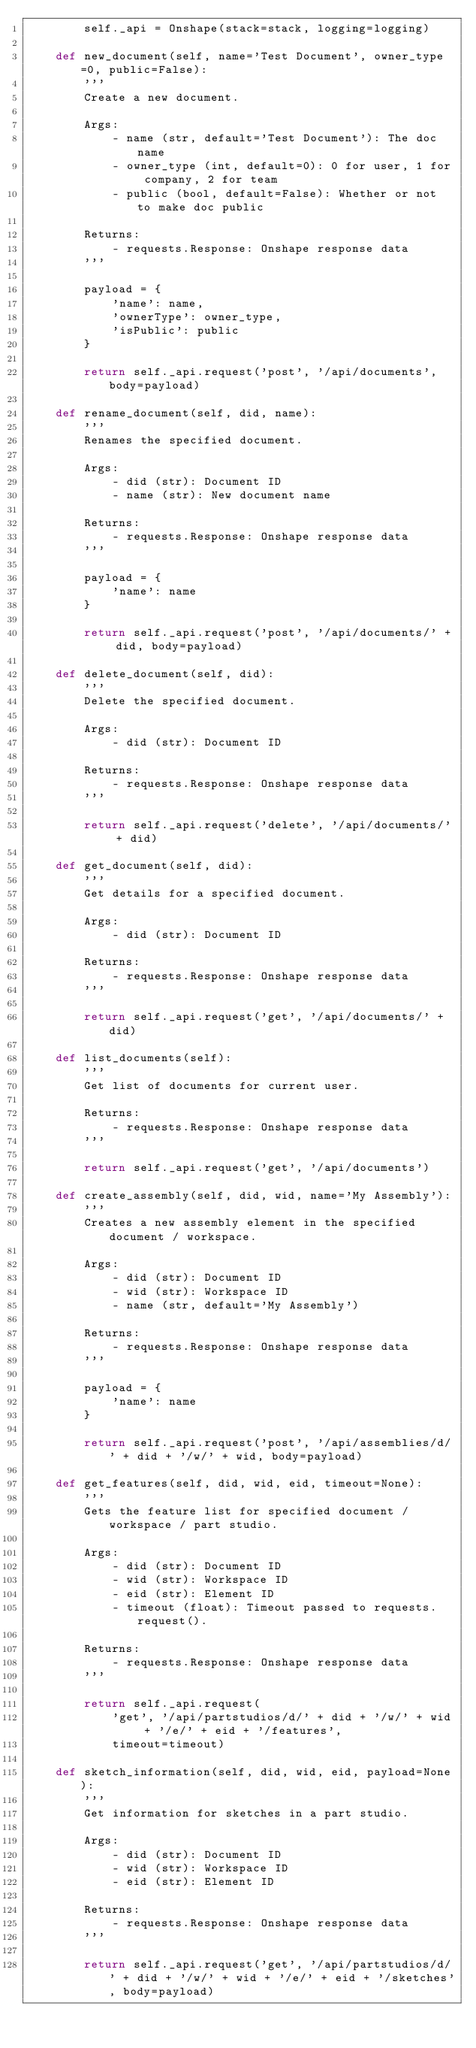Convert code to text. <code><loc_0><loc_0><loc_500><loc_500><_Python_>        self._api = Onshape(stack=stack, logging=logging)

    def new_document(self, name='Test Document', owner_type=0, public=False):
        '''
        Create a new document.

        Args:
            - name (str, default='Test Document'): The doc name
            - owner_type (int, default=0): 0 for user, 1 for company, 2 for team
            - public (bool, default=False): Whether or not to make doc public

        Returns:
            - requests.Response: Onshape response data
        '''

        payload = {
            'name': name,
            'ownerType': owner_type,
            'isPublic': public
        }

        return self._api.request('post', '/api/documents', body=payload)

    def rename_document(self, did, name):
        '''
        Renames the specified document.

        Args:
            - did (str): Document ID
            - name (str): New document name

        Returns:
            - requests.Response: Onshape response data
        '''

        payload = {
            'name': name
        }

        return self._api.request('post', '/api/documents/' + did, body=payload)

    def delete_document(self, did):
        '''
        Delete the specified document.

        Args:
            - did (str): Document ID

        Returns:
            - requests.Response: Onshape response data
        '''

        return self._api.request('delete', '/api/documents/' + did)

    def get_document(self, did):
        '''
        Get details for a specified document.

        Args:
            - did (str): Document ID

        Returns:
            - requests.Response: Onshape response data
        '''

        return self._api.request('get', '/api/documents/' + did)

    def list_documents(self):
        '''
        Get list of documents for current user.

        Returns:
            - requests.Response: Onshape response data
        '''

        return self._api.request('get', '/api/documents')

    def create_assembly(self, did, wid, name='My Assembly'):
        '''
        Creates a new assembly element in the specified document / workspace.

        Args:
            - did (str): Document ID
            - wid (str): Workspace ID
            - name (str, default='My Assembly')

        Returns:
            - requests.Response: Onshape response data
        '''

        payload = {
            'name': name
        }

        return self._api.request('post', '/api/assemblies/d/' + did + '/w/' + wid, body=payload)

    def get_features(self, did, wid, eid, timeout=None):
        '''
        Gets the feature list for specified document / workspace / part studio.

        Args:
            - did (str): Document ID
            - wid (str): Workspace ID
            - eid (str): Element ID
            - timeout (float): Timeout passed to requests.request().

        Returns:
            - requests.Response: Onshape response data
        '''

        return self._api.request(
            'get', '/api/partstudios/d/' + did + '/w/' + wid + '/e/' + eid + '/features',
            timeout=timeout)

    def sketch_information(self, did, wid, eid, payload=None):
        '''
        Get information for sketches in a part studio.

        Args:
            - did (str): Document ID
            - wid (str): Workspace ID
            - eid (str): Element ID

        Returns:
            - requests.Response: Onshape response data
        '''

        return self._api.request('get', '/api/partstudios/d/' + did + '/w/' + wid + '/e/' + eid + '/sketches', body=payload)
</code> 